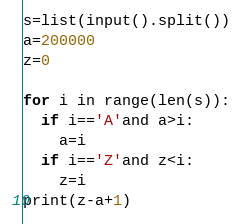<code> <loc_0><loc_0><loc_500><loc_500><_Python_>s=list(input().split())
a=200000
z=0

for i in range(len(s)):
  if i=='A'and a>i:
    a=i
  if i=='Z'and z<i:
    z=i
print(z-a+1)</code> 